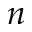<formula> <loc_0><loc_0><loc_500><loc_500>n</formula> 